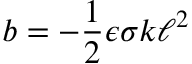<formula> <loc_0><loc_0><loc_500><loc_500>b = - \frac { 1 } { 2 } \epsilon \sigma k \ell ^ { 2 }</formula> 